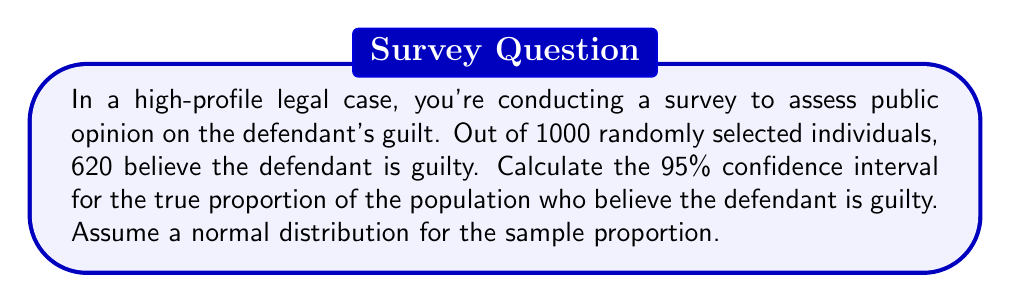Teach me how to tackle this problem. To calculate the confidence interval for a proportion, we'll use the following formula:

$$ CI = \hat{p} \pm z \sqrt{\frac{\hat{p}(1-\hat{p})}{n}} $$

Where:
- $\hat{p}$ is the sample proportion
- $z$ is the z-score for the desired confidence level
- $n$ is the sample size

Step 1: Calculate the sample proportion $\hat{p}$
$$ \hat{p} = \frac{620}{1000} = 0.62 $$

Step 2: Determine the z-score for a 95% confidence interval
For a 95% confidence interval, $z = 1.96$

Step 3: Calculate the standard error of the proportion
$$ SE = \sqrt{\frac{\hat{p}(1-\hat{p})}{n}} = \sqrt{\frac{0.62(1-0.62)}{1000}} = 0.0153 $$

Step 4: Calculate the margin of error
$$ ME = z \cdot SE = 1.96 \cdot 0.0153 = 0.0300 $$

Step 5: Calculate the confidence interval
$$ CI = 0.62 \pm 0.0300 $$

Lower bound: $0.62 - 0.0300 = 0.5900$
Upper bound: $0.62 + 0.0300 = 0.6500$

Therefore, the 95% confidence interval is (0.5900, 0.6500) or (59.00%, 65.00%).
Answer: The 95% confidence interval for the true proportion of the population who believe the defendant is guilty is (0.5900, 0.6500) or (59.00%, 65.00%). 